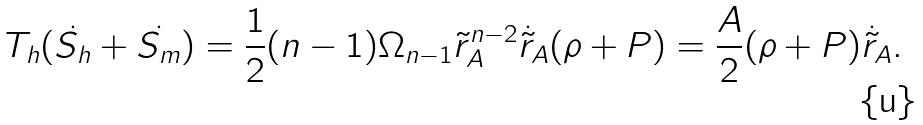<formula> <loc_0><loc_0><loc_500><loc_500>T _ { h } ( \dot { S _ { h } } + \dot { S _ { m } } ) = \frac { 1 } { 2 } ( n - 1 ) \Omega _ { n - 1 } { \tilde { r } _ { A } } ^ { n - 2 } \dot { \tilde { r } } _ { A } ( \rho + P ) = \frac { A } { 2 } ( \rho + P ) \dot { \tilde { r } } _ { A } .</formula> 